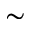<formula> <loc_0><loc_0><loc_500><loc_500>\sim</formula> 